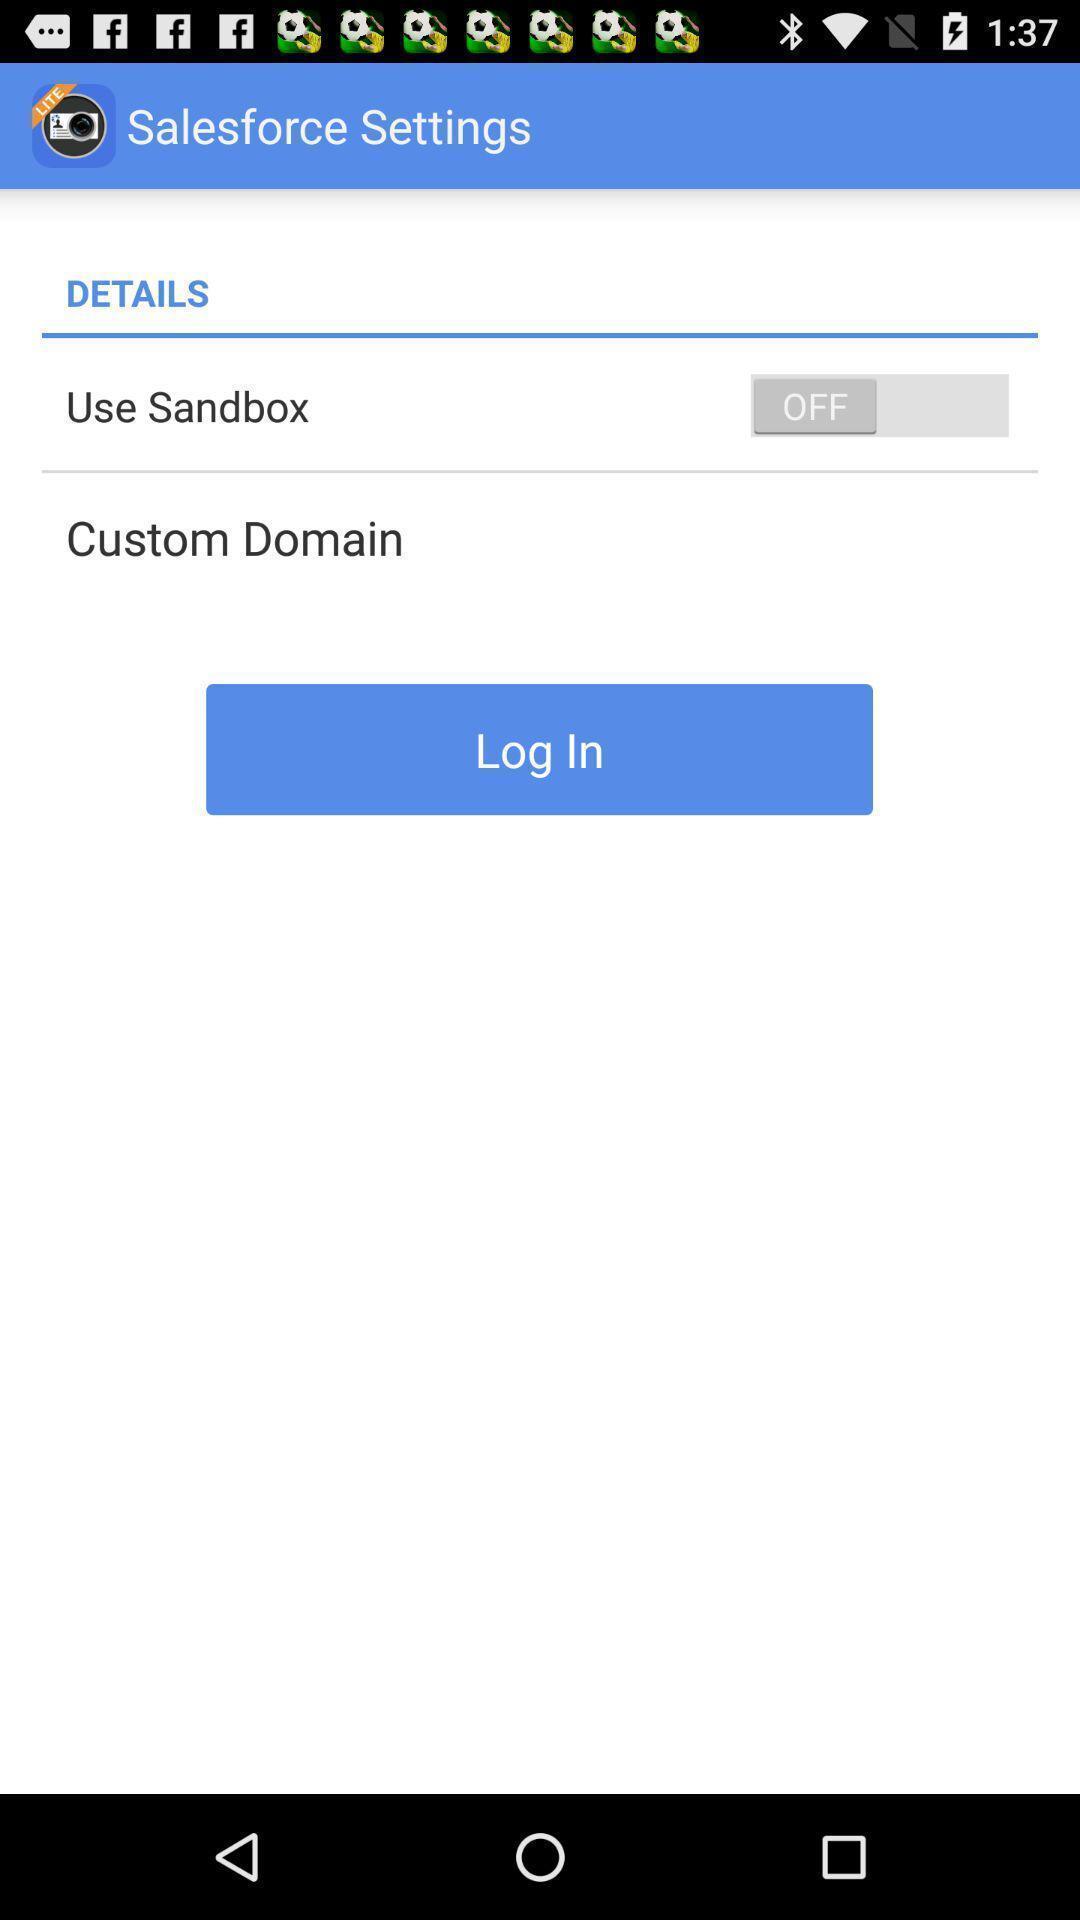What details can you identify in this image? Salesforce settings page in a business card app. 